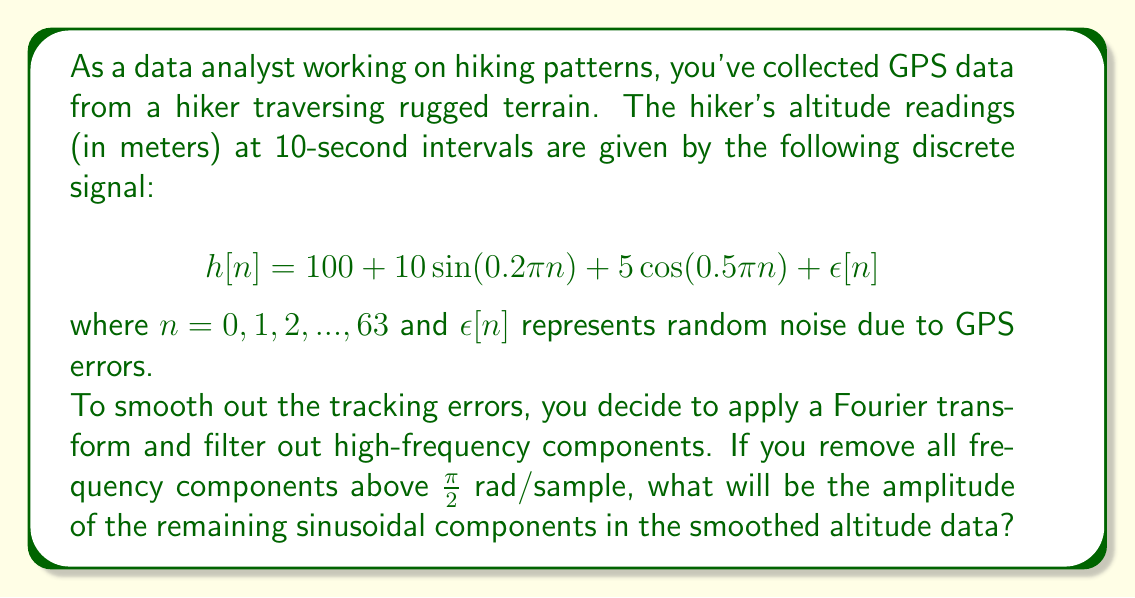Show me your answer to this math problem. Let's approach this step-by-step:

1) First, we need to identify the frequency components in the original signal:
   
   $$h[n] = 100 + 10\sin(0.2\pi n) + 5\cos(0.5\pi n) + \epsilon[n]$$

   - The constant term 100 represents the DC component (frequency = 0)
   - $\sin(0.2\pi n)$ has a frequency of 0.2π rad/sample
   - $\cos(0.5\pi n)$ has a frequency of 0.5π rad/sample
   - $\epsilon[n]$ represents noise, which typically contains high-frequency components

2) We're told to remove all frequency components above $\frac{\pi}{2}$ rad/sample.

3) Let's check which components will remain after filtering:
   
   - The DC component (100) will always remain as it has zero frequency.
   - $\sin(0.2\pi n)$ has a frequency of 0.2π, which is less than $\frac{\pi}{2}$, so it remains.
   - $\cos(0.5\pi n)$ has a frequency of 0.5π, which is equal to $\frac{\pi}{2}$, so it remains.
   - The noise $\epsilon[n]$ will be mostly removed as it typically contains high frequencies.

4) Therefore, after filtering, our signal will approximately look like:

   $$h_{filtered}[n] \approx 100 + 10\sin(0.2\pi n) + 5\cos(0.5\pi n)$$

5) The amplitudes of the remaining sinusoidal components are:
   - 10 for the $\sin(0.2\pi n)$ term
   - 5 for the $\cos(0.5\pi n)$ term
Answer: The amplitudes of the remaining sinusoidal components in the smoothed altitude data are 10 meters and 5 meters. 